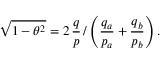<formula> <loc_0><loc_0><loc_500><loc_500>\sqrt { 1 - \theta ^ { 2 } } = 2 \, \frac { q } { p } \, / \left ( \frac { q _ { a } } { p _ { a } } + \frac { q _ { b } } { p _ { b } } \right ) .</formula> 